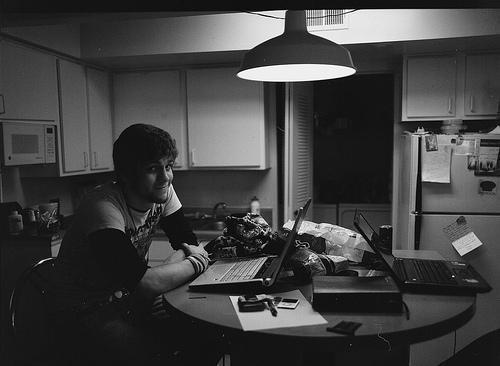How many laptops are on the table?
Give a very brief answer. 2. 